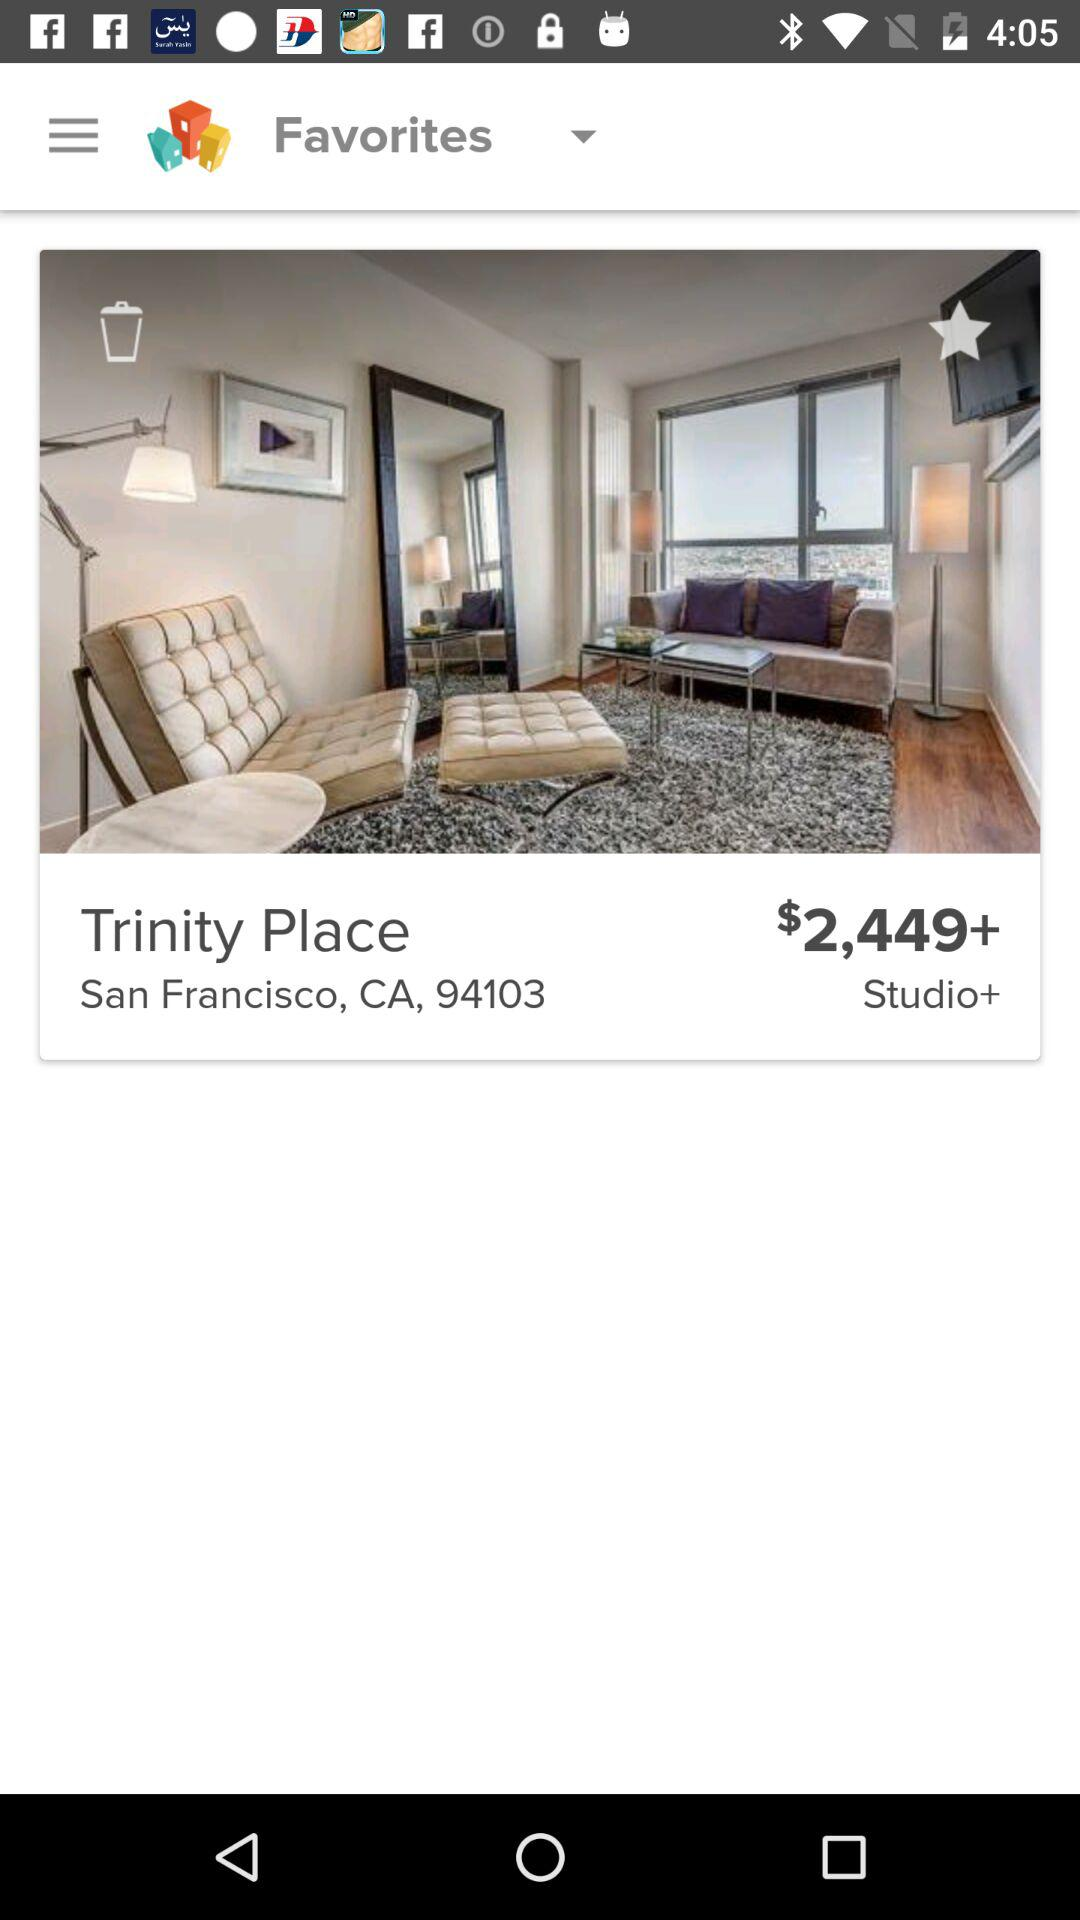What is the zipcode? The zipcode is 94103. 